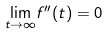<formula> <loc_0><loc_0><loc_500><loc_500>\underset { t \rightarrow \infty } { \lim } f ^ { \prime \prime } ( t ) = 0</formula> 